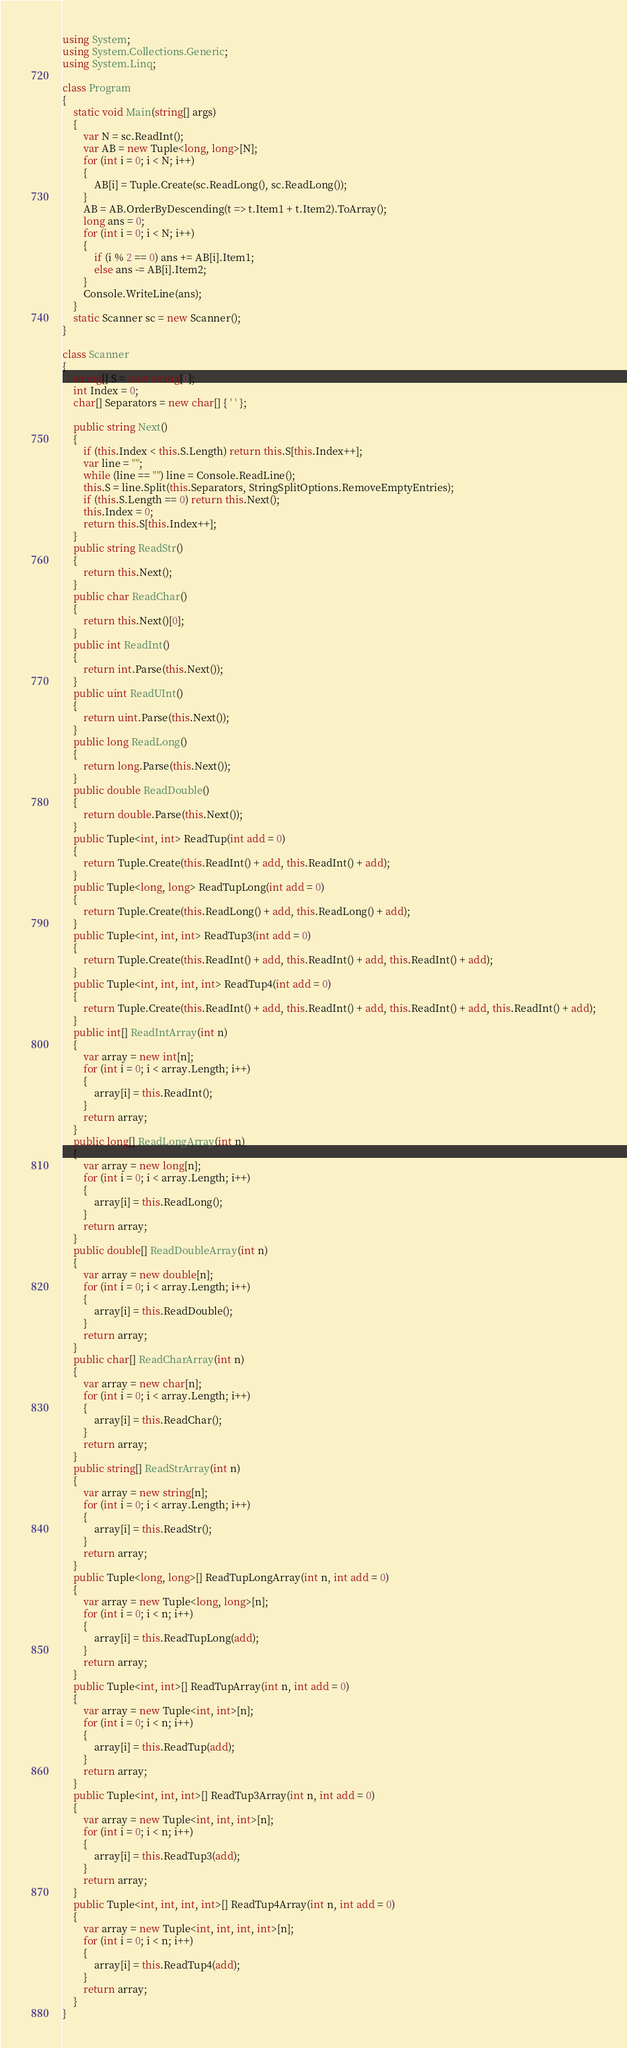Convert code to text. <code><loc_0><loc_0><loc_500><loc_500><_C#_>using System;
using System.Collections.Generic;
using System.Linq;

class Program
{
    static void Main(string[] args)
    {
        var N = sc.ReadInt();
        var AB = new Tuple<long, long>[N];
        for (int i = 0; i < N; i++)
        {
            AB[i] = Tuple.Create(sc.ReadLong(), sc.ReadLong());
        }
        AB = AB.OrderByDescending(t => t.Item1 + t.Item2).ToArray();
        long ans = 0;
        for (int i = 0; i < N; i++)
        {
            if (i % 2 == 0) ans += AB[i].Item1;
            else ans -= AB[i].Item2;
        }
        Console.WriteLine(ans);
    }
    static Scanner sc = new Scanner();
}

class Scanner
{
    string[] S = new string[0];
    int Index = 0;
    char[] Separators = new char[] { ' ' };

    public string Next()
    {
        if (this.Index < this.S.Length) return this.S[this.Index++];
        var line = "";
        while (line == "") line = Console.ReadLine();
        this.S = line.Split(this.Separators, StringSplitOptions.RemoveEmptyEntries);
        if (this.S.Length == 0) return this.Next();
        this.Index = 0;
        return this.S[this.Index++];
    }
    public string ReadStr()
    {
        return this.Next();
    }
    public char ReadChar()
    {
        return this.Next()[0];
    }
    public int ReadInt()
    {
        return int.Parse(this.Next());
    }
    public uint ReadUInt()
    {
        return uint.Parse(this.Next());
    }
    public long ReadLong()
    {
        return long.Parse(this.Next());
    }
    public double ReadDouble()
    {
        return double.Parse(this.Next());
    }
    public Tuple<int, int> ReadTup(int add = 0)
    {
        return Tuple.Create(this.ReadInt() + add, this.ReadInt() + add);
    }
    public Tuple<long, long> ReadTupLong(int add = 0)
    {
        return Tuple.Create(this.ReadLong() + add, this.ReadLong() + add);
    }
    public Tuple<int, int, int> ReadTup3(int add = 0)
    {
        return Tuple.Create(this.ReadInt() + add, this.ReadInt() + add, this.ReadInt() + add);
    }
    public Tuple<int, int, int, int> ReadTup4(int add = 0)
    {
        return Tuple.Create(this.ReadInt() + add, this.ReadInt() + add, this.ReadInt() + add, this.ReadInt() + add);
    }
    public int[] ReadIntArray(int n)
    {
        var array = new int[n];
        for (int i = 0; i < array.Length; i++)
        {
            array[i] = this.ReadInt();
        }
        return array;
    }
    public long[] ReadLongArray(int n)
    {
        var array = new long[n];
        for (int i = 0; i < array.Length; i++)
        {
            array[i] = this.ReadLong();
        }
        return array;
    }
    public double[] ReadDoubleArray(int n)
    {
        var array = new double[n];
        for (int i = 0; i < array.Length; i++)
        {
            array[i] = this.ReadDouble();
        }
        return array;
    }
    public char[] ReadCharArray(int n)
    {
        var array = new char[n];
        for (int i = 0; i < array.Length; i++)
        {
            array[i] = this.ReadChar();
        }
        return array;
    }
    public string[] ReadStrArray(int n)
    {
        var array = new string[n];
        for (int i = 0; i < array.Length; i++)
        {
            array[i] = this.ReadStr();
        }
        return array;
    }
    public Tuple<long, long>[] ReadTupLongArray(int n, int add = 0)
    {
        var array = new Tuple<long, long>[n];
        for (int i = 0; i < n; i++)
        {
            array[i] = this.ReadTupLong(add);
        }
        return array;
    }
    public Tuple<int, int>[] ReadTupArray(int n, int add = 0)
    {
        var array = new Tuple<int, int>[n];
        for (int i = 0; i < n; i++)
        {
            array[i] = this.ReadTup(add);
        }
        return array;
    }
    public Tuple<int, int, int>[] ReadTup3Array(int n, int add = 0)
    {
        var array = new Tuple<int, int, int>[n];
        for (int i = 0; i < n; i++)
        {
            array[i] = this.ReadTup3(add);
        }
        return array;
    }
    public Tuple<int, int, int, int>[] ReadTup4Array(int n, int add = 0)
    {
        var array = new Tuple<int, int, int, int>[n];
        for (int i = 0; i < n; i++)
        {
            array[i] = this.ReadTup4(add);
        }
        return array;
    }
}
</code> 